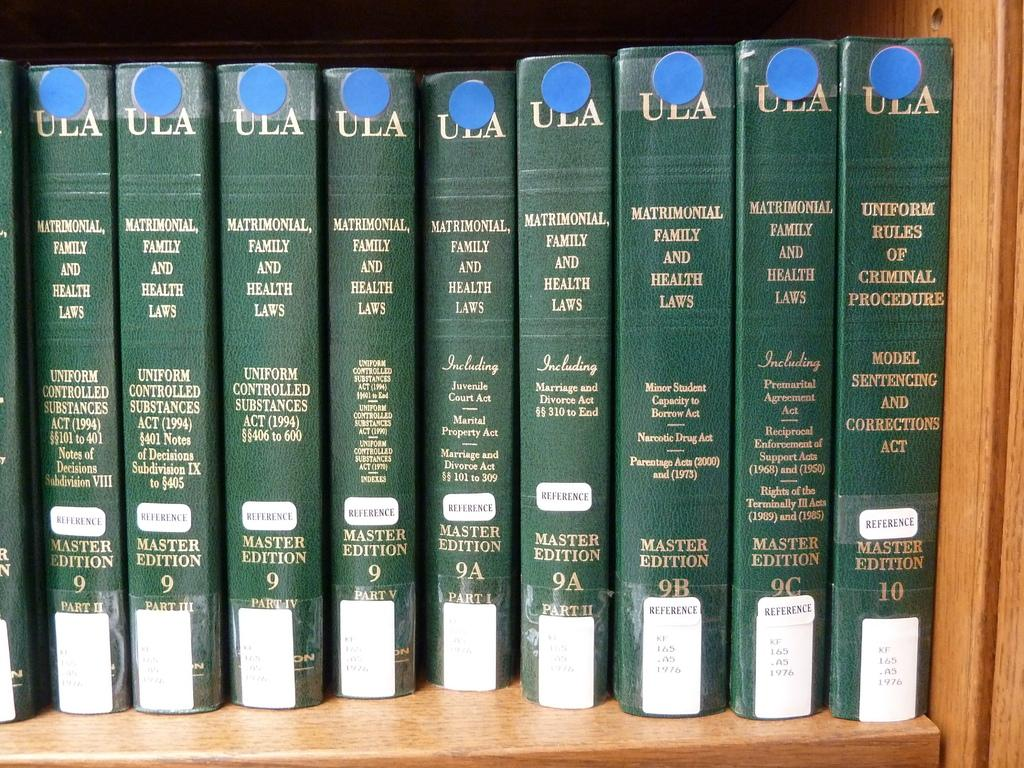<image>
Relay a brief, clear account of the picture shown. A line of books titled matrimonal, family and health laws. 